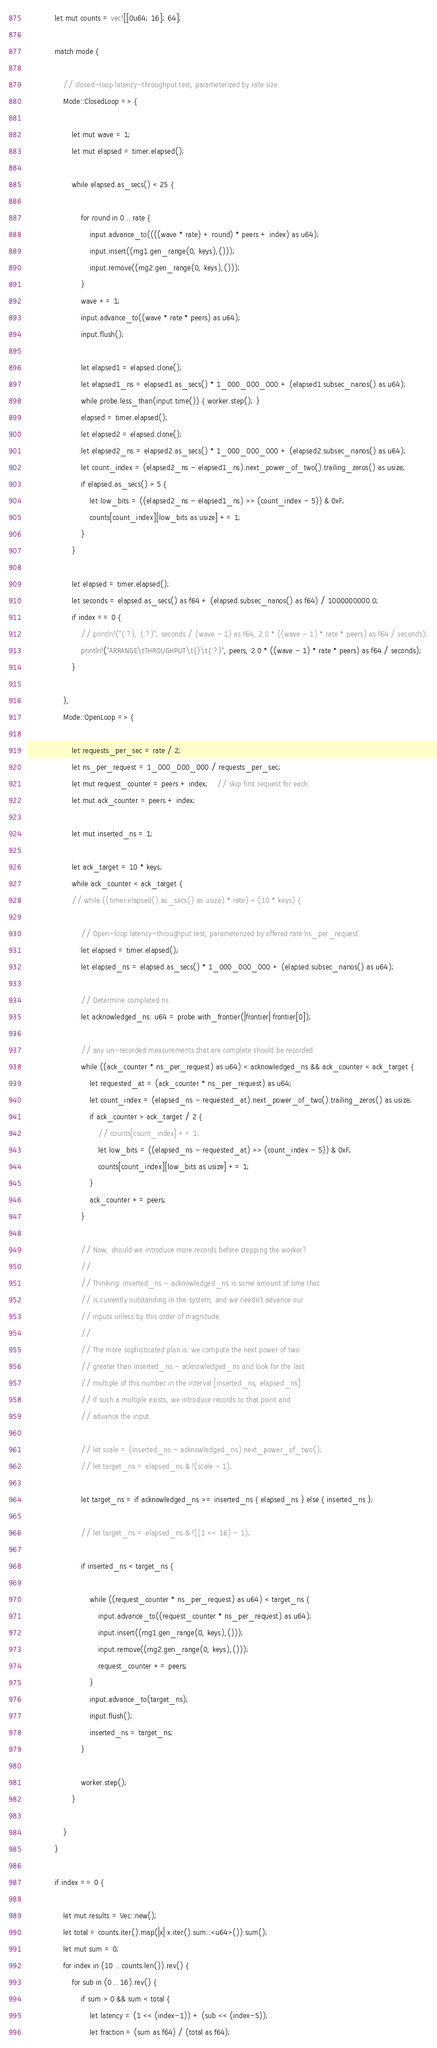<code> <loc_0><loc_0><loc_500><loc_500><_Rust_>
            let mut counts = vec![[0u64; 16]; 64];

            match mode {

                // closed-loop latency-throughput test, parameterized by rate size.
                Mode::ClosedLoop => {

                    let mut wave = 1;
                    let mut elapsed = timer.elapsed();

                    while elapsed.as_secs() < 25 {

                        for round in 0 .. rate {
                            input.advance_to((((wave * rate) + round) * peers + index) as u64);
                            input.insert((rng1.gen_range(0, keys),()));
                            input.remove((rng2.gen_range(0, keys),()));
                        }
                        wave += 1;
                        input.advance_to((wave * rate * peers) as u64);
                        input.flush();

                        let elapsed1 = elapsed.clone();
                        let elapsed1_ns = elapsed1.as_secs() * 1_000_000_000 + (elapsed1.subsec_nanos() as u64);
                        while probe.less_than(input.time()) { worker.step(); }
                        elapsed = timer.elapsed();
                        let elapsed2 = elapsed.clone();
                        let elapsed2_ns = elapsed2.as_secs() * 1_000_000_000 + (elapsed2.subsec_nanos() as u64);
                        let count_index = (elapsed2_ns - elapsed1_ns).next_power_of_two().trailing_zeros() as usize;
                        if elapsed.as_secs() > 5 {
                            let low_bits = ((elapsed2_ns - elapsed1_ns) >> (count_index - 5)) & 0xF;
                            counts[count_index][low_bits as usize] += 1;
                        }
                    }

                    let elapsed = timer.elapsed();
                    let seconds = elapsed.as_secs() as f64 + (elapsed.subsec_nanos() as f64) / 1000000000.0;
                    if index == 0 {
                        // println!("{:?}, {:?}", seconds / (wave - 1) as f64, 2.0 * ((wave - 1) * rate * peers) as f64 / seconds);
                        println!("ARRANGE\tTHROUGHPUT\t{}\t{:?}", peers, 2.0 * ((wave - 1) * rate * peers) as f64 / seconds);
                    }

                },
                Mode::OpenLoop => {

                    let requests_per_sec = rate / 2;
                    let ns_per_request = 1_000_000_000 / requests_per_sec;
                    let mut request_counter = peers + index;    // skip first request for each.
                    let mut ack_counter = peers + index;

                    let mut inserted_ns = 1;

                    let ack_target = 10 * keys;
                    while ack_counter < ack_target {
                    // while ((timer.elapsed().as_secs() as usize) * rate) < (10 * keys) {

                        // Open-loop latency-throughput test, parameterized by offered rate `ns_per_request`.
                        let elapsed = timer.elapsed();
                        let elapsed_ns = elapsed.as_secs() * 1_000_000_000 + (elapsed.subsec_nanos() as u64);

                        // Determine completed ns.
                        let acknowledged_ns: u64 = probe.with_frontier(|frontier| frontier[0]);

                        // any un-recorded measurements that are complete should be recorded.
                        while ((ack_counter * ns_per_request) as u64) < acknowledged_ns && ack_counter < ack_target {
                            let requested_at = (ack_counter * ns_per_request) as u64;
                            let count_index = (elapsed_ns - requested_at).next_power_of_two().trailing_zeros() as usize;
                            if ack_counter > ack_target / 2 {
                                // counts[count_index] += 1;
                                let low_bits = ((elapsed_ns - requested_at) >> (count_index - 5)) & 0xF;
                                counts[count_index][low_bits as usize] += 1;
                            }
                            ack_counter += peers;
                        }

                        // Now, should we introduce more records before stepping the worker?
                        //
                        // Thinking: inserted_ns - acknowledged_ns is some amount of time that
                        // is currently outstanding in the system, and we needn't advance our
                        // inputs unless by this order of magnitude.
                        //
                        // The more sophisticated plan is: we compute the next power of two
                        // greater than inserted_ns - acknowledged_ns and look for the last
                        // multiple of this number in the interval [inserted_ns, elapsed_ns].
                        // If such a multiple exists, we introduce records to that point and
                        // advance the input.

                        // let scale = (inserted_ns - acknowledged_ns).next_power_of_two();
                        // let target_ns = elapsed_ns & !(scale - 1);

                        let target_ns = if acknowledged_ns >= inserted_ns { elapsed_ns } else { inserted_ns };

                        // let target_ns = elapsed_ns & !((1 << 16) - 1);

                        if inserted_ns < target_ns {

                            while ((request_counter * ns_per_request) as u64) < target_ns {
                                input.advance_to((request_counter * ns_per_request) as u64);
                                input.insert((rng1.gen_range(0, keys),()));
                                input.remove((rng2.gen_range(0, keys),()));
                                request_counter += peers;
                            }
                            input.advance_to(target_ns);
                            input.flush();
                            inserted_ns = target_ns;
                        }

                        worker.step();
                    }

                }
            }

            if index == 0 {

                let mut results = Vec::new();
                let total = counts.iter().map(|x| x.iter().sum::<u64>()).sum();
                let mut sum = 0;
                for index in (10 .. counts.len()).rev() {
                    for sub in (0 .. 16).rev() {
                        if sum > 0 && sum < total {
                            let latency = (1 << (index-1)) + (sub << (index-5));
                            let fraction = (sum as f64) / (total as f64);</code> 